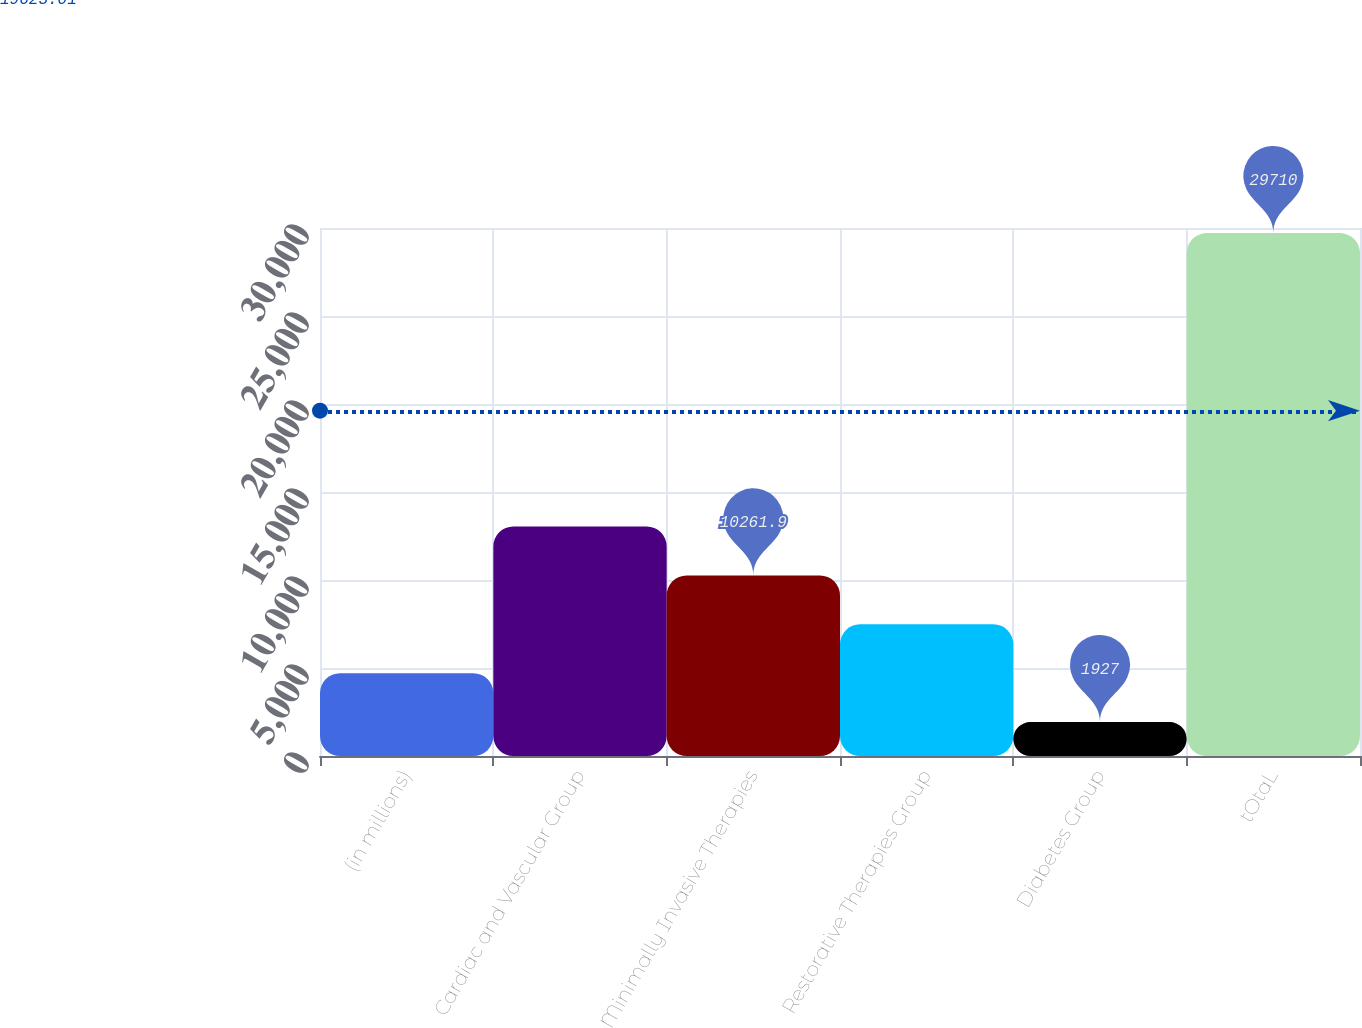<chart> <loc_0><loc_0><loc_500><loc_500><bar_chart><fcel>(in millions)<fcel>Cardiac and Vascular Group<fcel>Minimally Invasive Therapies<fcel>Restorative Therapies Group<fcel>Diabetes Group<fcel>tOtaL<nl><fcel>4705.3<fcel>13040.2<fcel>10261.9<fcel>7483.6<fcel>1927<fcel>29710<nl></chart> 